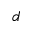Convert formula to latex. <formula><loc_0><loc_0><loc_500><loc_500>d</formula> 